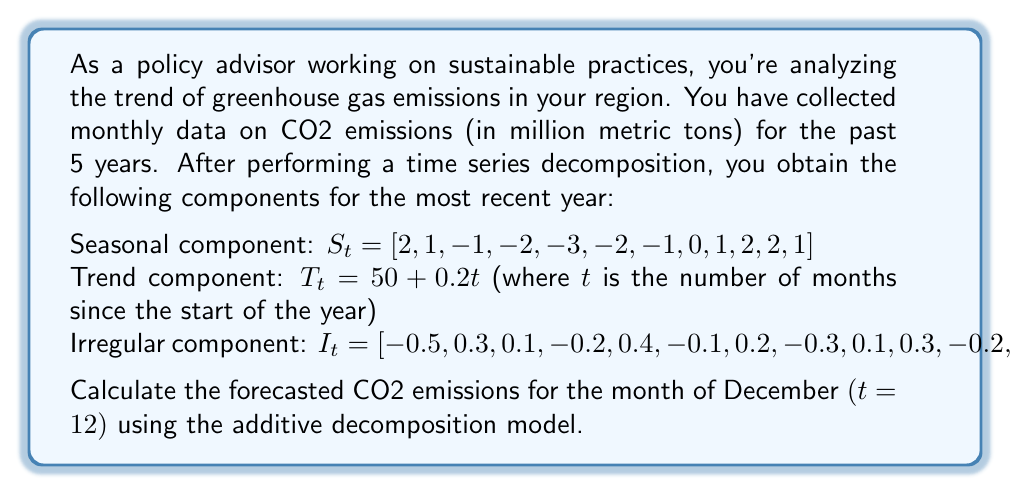Can you solve this math problem? To solve this problem, we'll use the additive decomposition model for time series analysis. In this model, the time series $Y_t$ is expressed as:

$$ Y_t = T_t + S_t + I_t $$

Where:
$T_t$ is the trend component
$S_t$ is the seasonal component
$I_t$ is the irregular component

Let's calculate each component for December (t = 12):

1. Trend component ($T_t$):
   $T_t = 50 + 0.2t$
   $T_{12} = 50 + 0.2(12) = 50 + 2.4 = 52.4$

2. Seasonal component ($S_t$):
   For December (12th month), $S_{12} = 1$

3. Irregular component ($I_t$):
   For December (12th month), $I_{12} = -0.1$

Now, we can combine these components using the additive model:

$$ Y_{12} = T_{12} + S_{12} + I_{12} $$
$$ Y_{12} = 52.4 + 1 + (-0.1) $$
$$ Y_{12} = 53.3 $$

Therefore, the forecasted CO2 emissions for December is 53.3 million metric tons.
Answer: 53.3 million metric tons 